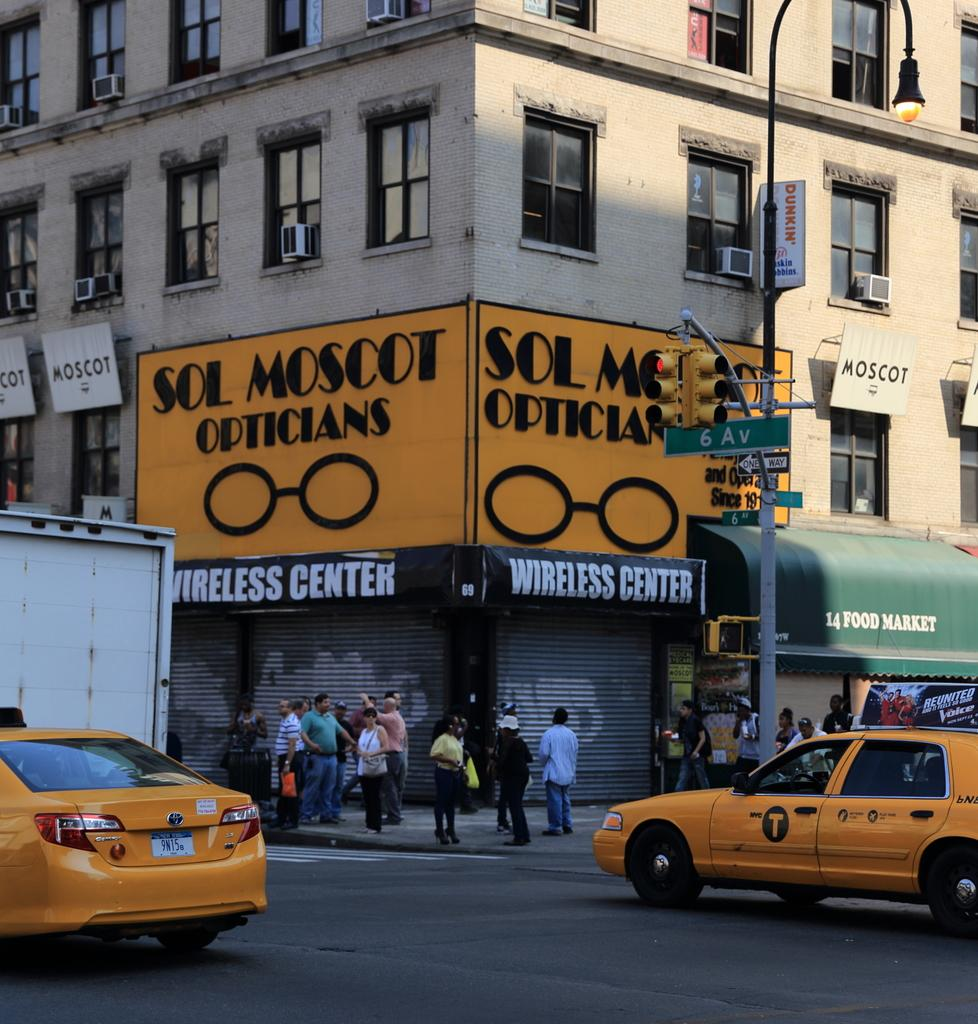<image>
Write a terse but informative summary of the picture. A corner store that is called Sol Moscot Opticians. 